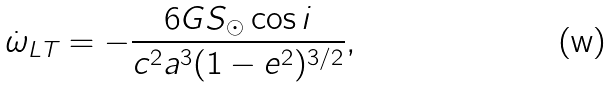<formula> <loc_0><loc_0><loc_500><loc_500>\dot { \omega } _ { L T } = - \frac { 6 G S _ { \odot } \cos i } { c ^ { 2 } a ^ { 3 } ( 1 - e ^ { 2 } ) ^ { 3 / 2 } } ,</formula> 